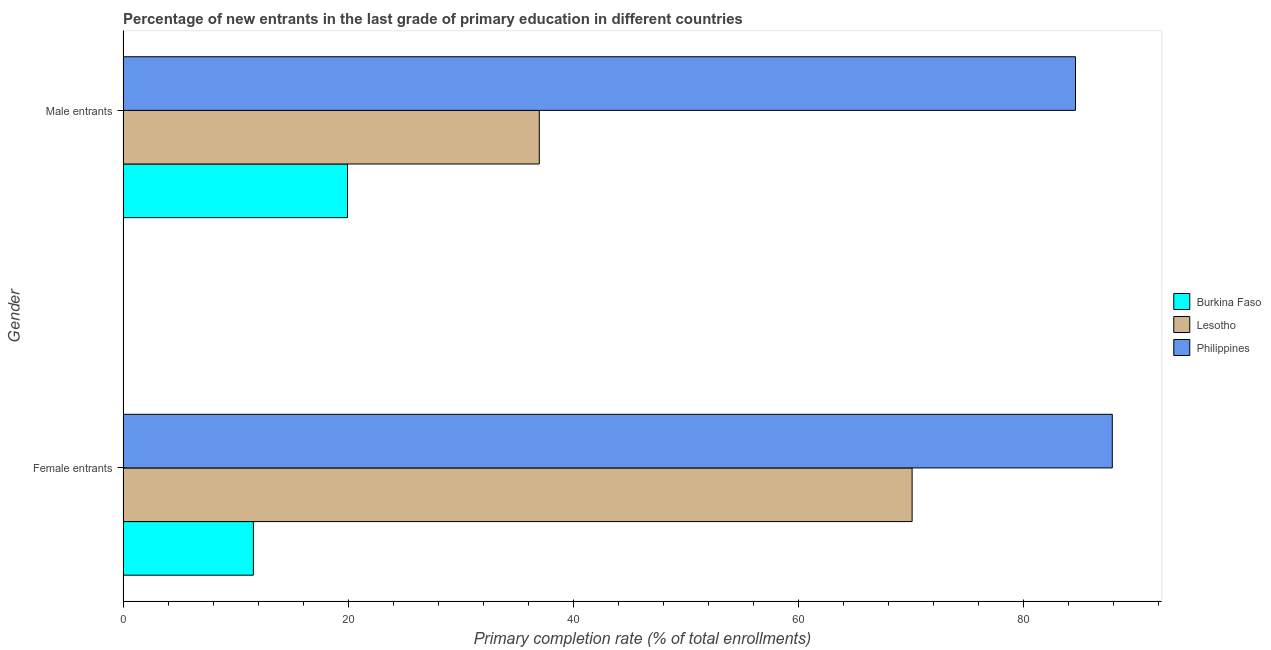How many bars are there on the 1st tick from the top?
Provide a succinct answer. 3. What is the label of the 1st group of bars from the top?
Make the answer very short. Male entrants. What is the primary completion rate of male entrants in Lesotho?
Give a very brief answer. 36.99. Across all countries, what is the maximum primary completion rate of female entrants?
Offer a terse response. 87.91. Across all countries, what is the minimum primary completion rate of female entrants?
Your response must be concise. 11.59. In which country was the primary completion rate of male entrants minimum?
Provide a succinct answer. Burkina Faso. What is the total primary completion rate of female entrants in the graph?
Keep it short and to the point. 169.61. What is the difference between the primary completion rate of female entrants in Lesotho and that in Burkina Faso?
Provide a short and direct response. 58.53. What is the difference between the primary completion rate of female entrants in Burkina Faso and the primary completion rate of male entrants in Lesotho?
Offer a terse response. -25.41. What is the average primary completion rate of female entrants per country?
Keep it short and to the point. 56.54. What is the difference between the primary completion rate of male entrants and primary completion rate of female entrants in Philippines?
Your answer should be very brief. -3.27. What is the ratio of the primary completion rate of female entrants in Lesotho to that in Burkina Faso?
Offer a terse response. 6.05. What does the 3rd bar from the top in Male entrants represents?
Provide a succinct answer. Burkina Faso. What does the 3rd bar from the bottom in Male entrants represents?
Your answer should be very brief. Philippines. Are the values on the major ticks of X-axis written in scientific E-notation?
Provide a short and direct response. No. Does the graph contain grids?
Your response must be concise. No. What is the title of the graph?
Offer a terse response. Percentage of new entrants in the last grade of primary education in different countries. What is the label or title of the X-axis?
Your answer should be very brief. Primary completion rate (% of total enrollments). What is the Primary completion rate (% of total enrollments) in Burkina Faso in Female entrants?
Offer a terse response. 11.59. What is the Primary completion rate (% of total enrollments) in Lesotho in Female entrants?
Offer a terse response. 70.12. What is the Primary completion rate (% of total enrollments) in Philippines in Female entrants?
Your answer should be very brief. 87.91. What is the Primary completion rate (% of total enrollments) in Burkina Faso in Male entrants?
Provide a short and direct response. 19.95. What is the Primary completion rate (% of total enrollments) in Lesotho in Male entrants?
Provide a succinct answer. 36.99. What is the Primary completion rate (% of total enrollments) in Philippines in Male entrants?
Keep it short and to the point. 84.64. Across all Gender, what is the maximum Primary completion rate (% of total enrollments) of Burkina Faso?
Provide a short and direct response. 19.95. Across all Gender, what is the maximum Primary completion rate (% of total enrollments) of Lesotho?
Your answer should be very brief. 70.12. Across all Gender, what is the maximum Primary completion rate (% of total enrollments) in Philippines?
Make the answer very short. 87.91. Across all Gender, what is the minimum Primary completion rate (% of total enrollments) of Burkina Faso?
Offer a terse response. 11.59. Across all Gender, what is the minimum Primary completion rate (% of total enrollments) of Lesotho?
Offer a very short reply. 36.99. Across all Gender, what is the minimum Primary completion rate (% of total enrollments) of Philippines?
Keep it short and to the point. 84.64. What is the total Primary completion rate (% of total enrollments) of Burkina Faso in the graph?
Provide a succinct answer. 31.54. What is the total Primary completion rate (% of total enrollments) in Lesotho in the graph?
Your response must be concise. 107.11. What is the total Primary completion rate (% of total enrollments) in Philippines in the graph?
Provide a short and direct response. 172.54. What is the difference between the Primary completion rate (% of total enrollments) of Burkina Faso in Female entrants and that in Male entrants?
Offer a very short reply. -8.36. What is the difference between the Primary completion rate (% of total enrollments) in Lesotho in Female entrants and that in Male entrants?
Offer a terse response. 33.13. What is the difference between the Primary completion rate (% of total enrollments) in Philippines in Female entrants and that in Male entrants?
Your answer should be compact. 3.27. What is the difference between the Primary completion rate (% of total enrollments) in Burkina Faso in Female entrants and the Primary completion rate (% of total enrollments) in Lesotho in Male entrants?
Your answer should be compact. -25.41. What is the difference between the Primary completion rate (% of total enrollments) in Burkina Faso in Female entrants and the Primary completion rate (% of total enrollments) in Philippines in Male entrants?
Give a very brief answer. -73.05. What is the difference between the Primary completion rate (% of total enrollments) of Lesotho in Female entrants and the Primary completion rate (% of total enrollments) of Philippines in Male entrants?
Give a very brief answer. -14.52. What is the average Primary completion rate (% of total enrollments) of Burkina Faso per Gender?
Provide a short and direct response. 15.77. What is the average Primary completion rate (% of total enrollments) in Lesotho per Gender?
Your answer should be very brief. 53.56. What is the average Primary completion rate (% of total enrollments) in Philippines per Gender?
Your response must be concise. 86.27. What is the difference between the Primary completion rate (% of total enrollments) in Burkina Faso and Primary completion rate (% of total enrollments) in Lesotho in Female entrants?
Ensure brevity in your answer.  -58.53. What is the difference between the Primary completion rate (% of total enrollments) of Burkina Faso and Primary completion rate (% of total enrollments) of Philippines in Female entrants?
Your answer should be very brief. -76.32. What is the difference between the Primary completion rate (% of total enrollments) of Lesotho and Primary completion rate (% of total enrollments) of Philippines in Female entrants?
Your answer should be compact. -17.79. What is the difference between the Primary completion rate (% of total enrollments) of Burkina Faso and Primary completion rate (% of total enrollments) of Lesotho in Male entrants?
Make the answer very short. -17.04. What is the difference between the Primary completion rate (% of total enrollments) in Burkina Faso and Primary completion rate (% of total enrollments) in Philippines in Male entrants?
Offer a terse response. -64.69. What is the difference between the Primary completion rate (% of total enrollments) in Lesotho and Primary completion rate (% of total enrollments) in Philippines in Male entrants?
Offer a very short reply. -47.65. What is the ratio of the Primary completion rate (% of total enrollments) in Burkina Faso in Female entrants to that in Male entrants?
Make the answer very short. 0.58. What is the ratio of the Primary completion rate (% of total enrollments) of Lesotho in Female entrants to that in Male entrants?
Keep it short and to the point. 1.9. What is the ratio of the Primary completion rate (% of total enrollments) of Philippines in Female entrants to that in Male entrants?
Your response must be concise. 1.04. What is the difference between the highest and the second highest Primary completion rate (% of total enrollments) in Burkina Faso?
Offer a very short reply. 8.36. What is the difference between the highest and the second highest Primary completion rate (% of total enrollments) of Lesotho?
Your answer should be compact. 33.13. What is the difference between the highest and the second highest Primary completion rate (% of total enrollments) in Philippines?
Provide a short and direct response. 3.27. What is the difference between the highest and the lowest Primary completion rate (% of total enrollments) of Burkina Faso?
Your answer should be compact. 8.36. What is the difference between the highest and the lowest Primary completion rate (% of total enrollments) in Lesotho?
Make the answer very short. 33.13. What is the difference between the highest and the lowest Primary completion rate (% of total enrollments) in Philippines?
Provide a short and direct response. 3.27. 